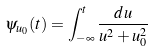<formula> <loc_0><loc_0><loc_500><loc_500>\psi _ { u _ { 0 } } ( t ) = \int _ { - \infty } ^ { t } \frac { d u } { u ^ { 2 } + u _ { 0 } ^ { 2 } }</formula> 